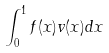<formula> <loc_0><loc_0><loc_500><loc_500>\int _ { 0 } ^ { 1 } f ( x ) v ( x ) d x</formula> 